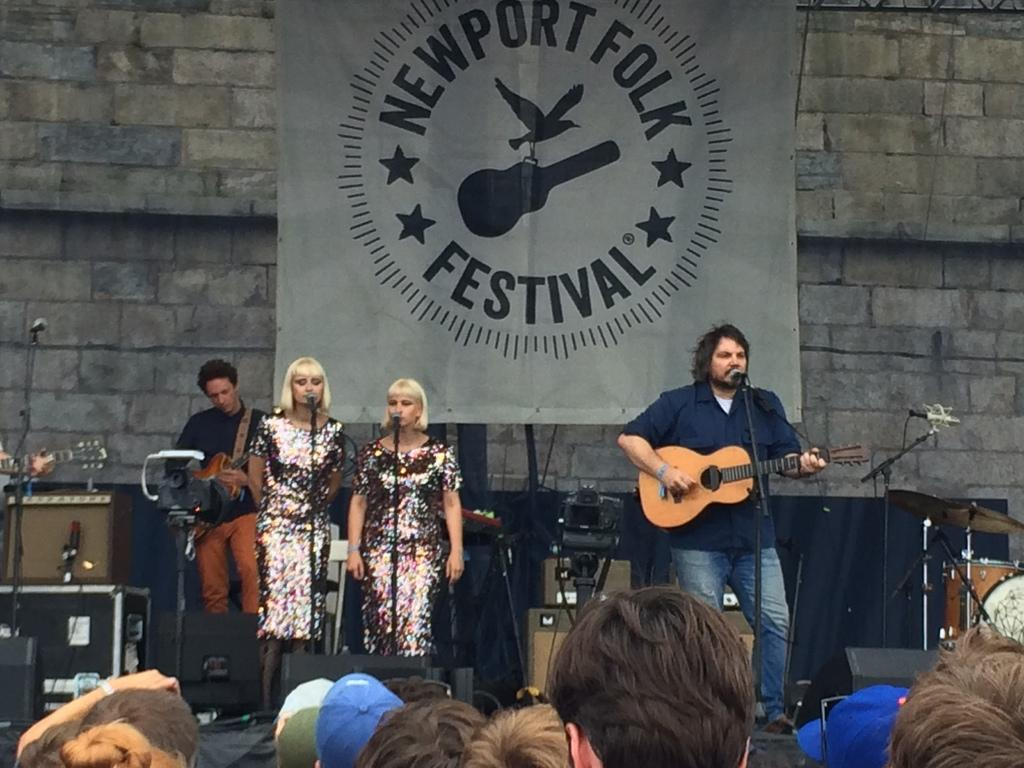What is happening on the stage in the image? There is a group of people performing on a stage. Are there any spectators present in the image? Yes, there are people watching the performance. What type of animals can be seen performing at the zoo in the image? There is no zoo or animals present in the image; it features a group of people performing on a stage. What is the purpose of the sheet in the image? There is no sheet present in the image. 